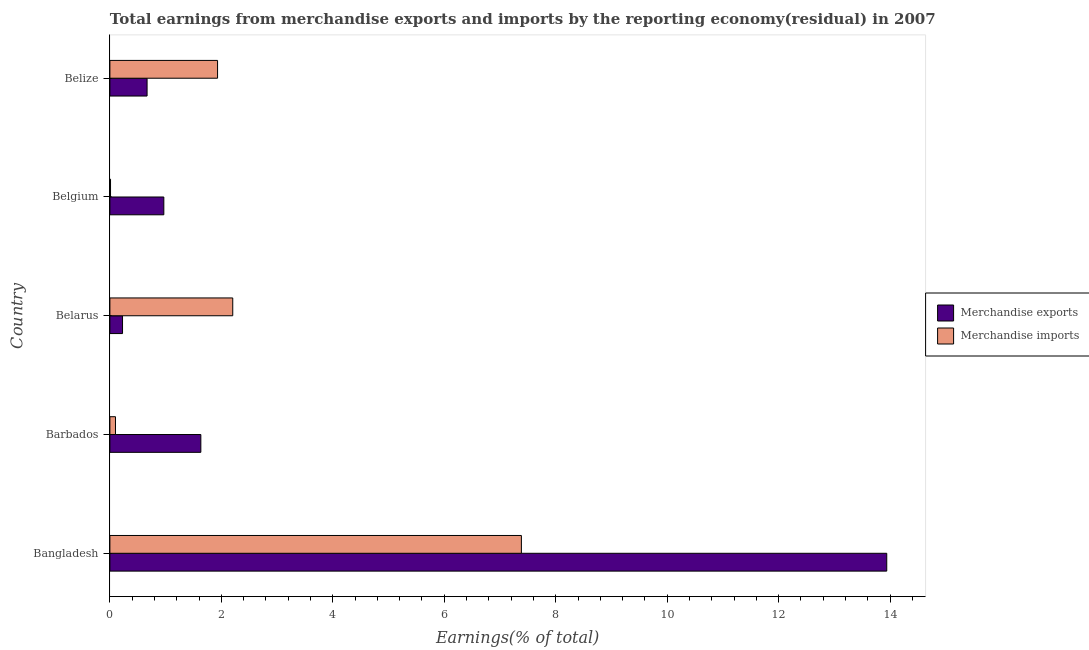How many different coloured bars are there?
Your answer should be compact. 2. Are the number of bars per tick equal to the number of legend labels?
Provide a short and direct response. Yes. How many bars are there on the 4th tick from the top?
Ensure brevity in your answer.  2. What is the label of the 2nd group of bars from the top?
Offer a terse response. Belgium. In how many cases, is the number of bars for a given country not equal to the number of legend labels?
Offer a very short reply. 0. What is the earnings from merchandise imports in Belgium?
Your response must be concise. 0.01. Across all countries, what is the maximum earnings from merchandise exports?
Your response must be concise. 13.94. Across all countries, what is the minimum earnings from merchandise exports?
Your answer should be very brief. 0.23. In which country was the earnings from merchandise exports maximum?
Your response must be concise. Bangladesh. What is the total earnings from merchandise exports in the graph?
Offer a very short reply. 17.43. What is the difference between the earnings from merchandise imports in Barbados and that in Belize?
Ensure brevity in your answer.  -1.83. What is the difference between the earnings from merchandise imports in Bangladesh and the earnings from merchandise exports in Barbados?
Ensure brevity in your answer.  5.75. What is the average earnings from merchandise imports per country?
Give a very brief answer. 2.33. What is the difference between the earnings from merchandise imports and earnings from merchandise exports in Belarus?
Keep it short and to the point. 1.98. In how many countries, is the earnings from merchandise exports greater than 6.8 %?
Keep it short and to the point. 1. What is the ratio of the earnings from merchandise exports in Bangladesh to that in Belgium?
Give a very brief answer. 14.4. Is the difference between the earnings from merchandise exports in Barbados and Belarus greater than the difference between the earnings from merchandise imports in Barbados and Belarus?
Provide a succinct answer. Yes. What is the difference between the highest and the second highest earnings from merchandise imports?
Keep it short and to the point. 5.18. What is the difference between the highest and the lowest earnings from merchandise imports?
Offer a terse response. 7.37. Is the sum of the earnings from merchandise exports in Barbados and Belarus greater than the maximum earnings from merchandise imports across all countries?
Your answer should be very brief. No. What does the 1st bar from the top in Belize represents?
Offer a terse response. Merchandise imports. What does the 2nd bar from the bottom in Belgium represents?
Your answer should be compact. Merchandise imports. How many bars are there?
Ensure brevity in your answer.  10. Are all the bars in the graph horizontal?
Offer a very short reply. Yes. How many countries are there in the graph?
Ensure brevity in your answer.  5. Are the values on the major ticks of X-axis written in scientific E-notation?
Give a very brief answer. No. Does the graph contain grids?
Provide a short and direct response. No. How are the legend labels stacked?
Offer a terse response. Vertical. What is the title of the graph?
Your response must be concise. Total earnings from merchandise exports and imports by the reporting economy(residual) in 2007. Does "Urban" appear as one of the legend labels in the graph?
Offer a very short reply. No. What is the label or title of the X-axis?
Provide a succinct answer. Earnings(% of total). What is the label or title of the Y-axis?
Your answer should be very brief. Country. What is the Earnings(% of total) of Merchandise exports in Bangladesh?
Keep it short and to the point. 13.94. What is the Earnings(% of total) in Merchandise imports in Bangladesh?
Offer a terse response. 7.38. What is the Earnings(% of total) in Merchandise exports in Barbados?
Your response must be concise. 1.63. What is the Earnings(% of total) in Merchandise imports in Barbados?
Provide a succinct answer. 0.1. What is the Earnings(% of total) in Merchandise exports in Belarus?
Your response must be concise. 0.23. What is the Earnings(% of total) of Merchandise imports in Belarus?
Offer a very short reply. 2.2. What is the Earnings(% of total) in Merchandise exports in Belgium?
Your response must be concise. 0.97. What is the Earnings(% of total) of Merchandise imports in Belgium?
Your answer should be very brief. 0.01. What is the Earnings(% of total) of Merchandise exports in Belize?
Your answer should be compact. 0.67. What is the Earnings(% of total) of Merchandise imports in Belize?
Provide a short and direct response. 1.93. Across all countries, what is the maximum Earnings(% of total) in Merchandise exports?
Offer a terse response. 13.94. Across all countries, what is the maximum Earnings(% of total) of Merchandise imports?
Ensure brevity in your answer.  7.38. Across all countries, what is the minimum Earnings(% of total) in Merchandise exports?
Make the answer very short. 0.23. Across all countries, what is the minimum Earnings(% of total) of Merchandise imports?
Offer a very short reply. 0.01. What is the total Earnings(% of total) of Merchandise exports in the graph?
Provide a short and direct response. 17.43. What is the total Earnings(% of total) in Merchandise imports in the graph?
Keep it short and to the point. 11.63. What is the difference between the Earnings(% of total) in Merchandise exports in Bangladesh and that in Barbados?
Offer a terse response. 12.31. What is the difference between the Earnings(% of total) in Merchandise imports in Bangladesh and that in Barbados?
Make the answer very short. 7.28. What is the difference between the Earnings(% of total) in Merchandise exports in Bangladesh and that in Belarus?
Offer a very short reply. 13.71. What is the difference between the Earnings(% of total) of Merchandise imports in Bangladesh and that in Belarus?
Your answer should be very brief. 5.18. What is the difference between the Earnings(% of total) of Merchandise exports in Bangladesh and that in Belgium?
Ensure brevity in your answer.  12.97. What is the difference between the Earnings(% of total) of Merchandise imports in Bangladesh and that in Belgium?
Offer a very short reply. 7.37. What is the difference between the Earnings(% of total) in Merchandise exports in Bangladesh and that in Belize?
Make the answer very short. 13.27. What is the difference between the Earnings(% of total) in Merchandise imports in Bangladesh and that in Belize?
Give a very brief answer. 5.45. What is the difference between the Earnings(% of total) of Merchandise exports in Barbados and that in Belarus?
Provide a succinct answer. 1.41. What is the difference between the Earnings(% of total) of Merchandise imports in Barbados and that in Belarus?
Keep it short and to the point. -2.1. What is the difference between the Earnings(% of total) in Merchandise exports in Barbados and that in Belgium?
Give a very brief answer. 0.66. What is the difference between the Earnings(% of total) of Merchandise imports in Barbados and that in Belgium?
Make the answer very short. 0.09. What is the difference between the Earnings(% of total) of Merchandise exports in Barbados and that in Belize?
Give a very brief answer. 0.96. What is the difference between the Earnings(% of total) of Merchandise imports in Barbados and that in Belize?
Make the answer very short. -1.83. What is the difference between the Earnings(% of total) of Merchandise exports in Belarus and that in Belgium?
Make the answer very short. -0.74. What is the difference between the Earnings(% of total) in Merchandise imports in Belarus and that in Belgium?
Give a very brief answer. 2.19. What is the difference between the Earnings(% of total) of Merchandise exports in Belarus and that in Belize?
Give a very brief answer. -0.44. What is the difference between the Earnings(% of total) of Merchandise imports in Belarus and that in Belize?
Provide a short and direct response. 0.27. What is the difference between the Earnings(% of total) in Merchandise exports in Belgium and that in Belize?
Offer a very short reply. 0.3. What is the difference between the Earnings(% of total) of Merchandise imports in Belgium and that in Belize?
Provide a short and direct response. -1.92. What is the difference between the Earnings(% of total) in Merchandise exports in Bangladesh and the Earnings(% of total) in Merchandise imports in Barbados?
Your answer should be compact. 13.84. What is the difference between the Earnings(% of total) in Merchandise exports in Bangladesh and the Earnings(% of total) in Merchandise imports in Belarus?
Keep it short and to the point. 11.74. What is the difference between the Earnings(% of total) in Merchandise exports in Bangladesh and the Earnings(% of total) in Merchandise imports in Belgium?
Offer a terse response. 13.93. What is the difference between the Earnings(% of total) of Merchandise exports in Bangladesh and the Earnings(% of total) of Merchandise imports in Belize?
Provide a short and direct response. 12.01. What is the difference between the Earnings(% of total) of Merchandise exports in Barbados and the Earnings(% of total) of Merchandise imports in Belarus?
Keep it short and to the point. -0.57. What is the difference between the Earnings(% of total) of Merchandise exports in Barbados and the Earnings(% of total) of Merchandise imports in Belgium?
Provide a succinct answer. 1.62. What is the difference between the Earnings(% of total) of Merchandise exports in Barbados and the Earnings(% of total) of Merchandise imports in Belize?
Make the answer very short. -0.3. What is the difference between the Earnings(% of total) of Merchandise exports in Belarus and the Earnings(% of total) of Merchandise imports in Belgium?
Give a very brief answer. 0.22. What is the difference between the Earnings(% of total) of Merchandise exports in Belarus and the Earnings(% of total) of Merchandise imports in Belize?
Offer a terse response. -1.71. What is the difference between the Earnings(% of total) of Merchandise exports in Belgium and the Earnings(% of total) of Merchandise imports in Belize?
Provide a succinct answer. -0.96. What is the average Earnings(% of total) in Merchandise exports per country?
Your answer should be compact. 3.49. What is the average Earnings(% of total) in Merchandise imports per country?
Give a very brief answer. 2.33. What is the difference between the Earnings(% of total) in Merchandise exports and Earnings(% of total) in Merchandise imports in Bangladesh?
Keep it short and to the point. 6.56. What is the difference between the Earnings(% of total) of Merchandise exports and Earnings(% of total) of Merchandise imports in Barbados?
Offer a very short reply. 1.53. What is the difference between the Earnings(% of total) in Merchandise exports and Earnings(% of total) in Merchandise imports in Belarus?
Offer a very short reply. -1.98. What is the difference between the Earnings(% of total) of Merchandise exports and Earnings(% of total) of Merchandise imports in Belgium?
Provide a succinct answer. 0.96. What is the difference between the Earnings(% of total) of Merchandise exports and Earnings(% of total) of Merchandise imports in Belize?
Make the answer very short. -1.26. What is the ratio of the Earnings(% of total) in Merchandise exports in Bangladesh to that in Barbados?
Provide a succinct answer. 8.54. What is the ratio of the Earnings(% of total) of Merchandise imports in Bangladesh to that in Barbados?
Your answer should be very brief. 73.48. What is the ratio of the Earnings(% of total) of Merchandise exports in Bangladesh to that in Belarus?
Offer a terse response. 61.48. What is the ratio of the Earnings(% of total) of Merchandise imports in Bangladesh to that in Belarus?
Give a very brief answer. 3.35. What is the ratio of the Earnings(% of total) in Merchandise exports in Bangladesh to that in Belgium?
Provide a succinct answer. 14.4. What is the ratio of the Earnings(% of total) in Merchandise imports in Bangladesh to that in Belgium?
Keep it short and to the point. 643.86. What is the ratio of the Earnings(% of total) in Merchandise exports in Bangladesh to that in Belize?
Ensure brevity in your answer.  20.89. What is the ratio of the Earnings(% of total) of Merchandise imports in Bangladesh to that in Belize?
Your answer should be very brief. 3.82. What is the ratio of the Earnings(% of total) in Merchandise exports in Barbados to that in Belarus?
Give a very brief answer. 7.2. What is the ratio of the Earnings(% of total) of Merchandise imports in Barbados to that in Belarus?
Keep it short and to the point. 0.05. What is the ratio of the Earnings(% of total) of Merchandise exports in Barbados to that in Belgium?
Your answer should be compact. 1.69. What is the ratio of the Earnings(% of total) of Merchandise imports in Barbados to that in Belgium?
Your answer should be compact. 8.76. What is the ratio of the Earnings(% of total) in Merchandise exports in Barbados to that in Belize?
Make the answer very short. 2.45. What is the ratio of the Earnings(% of total) in Merchandise imports in Barbados to that in Belize?
Offer a very short reply. 0.05. What is the ratio of the Earnings(% of total) in Merchandise exports in Belarus to that in Belgium?
Your response must be concise. 0.23. What is the ratio of the Earnings(% of total) in Merchandise imports in Belarus to that in Belgium?
Your answer should be very brief. 192.22. What is the ratio of the Earnings(% of total) of Merchandise exports in Belarus to that in Belize?
Give a very brief answer. 0.34. What is the ratio of the Earnings(% of total) of Merchandise imports in Belarus to that in Belize?
Give a very brief answer. 1.14. What is the ratio of the Earnings(% of total) of Merchandise exports in Belgium to that in Belize?
Your answer should be compact. 1.45. What is the ratio of the Earnings(% of total) of Merchandise imports in Belgium to that in Belize?
Your answer should be very brief. 0.01. What is the difference between the highest and the second highest Earnings(% of total) of Merchandise exports?
Provide a short and direct response. 12.31. What is the difference between the highest and the second highest Earnings(% of total) of Merchandise imports?
Ensure brevity in your answer.  5.18. What is the difference between the highest and the lowest Earnings(% of total) of Merchandise exports?
Keep it short and to the point. 13.71. What is the difference between the highest and the lowest Earnings(% of total) of Merchandise imports?
Offer a very short reply. 7.37. 